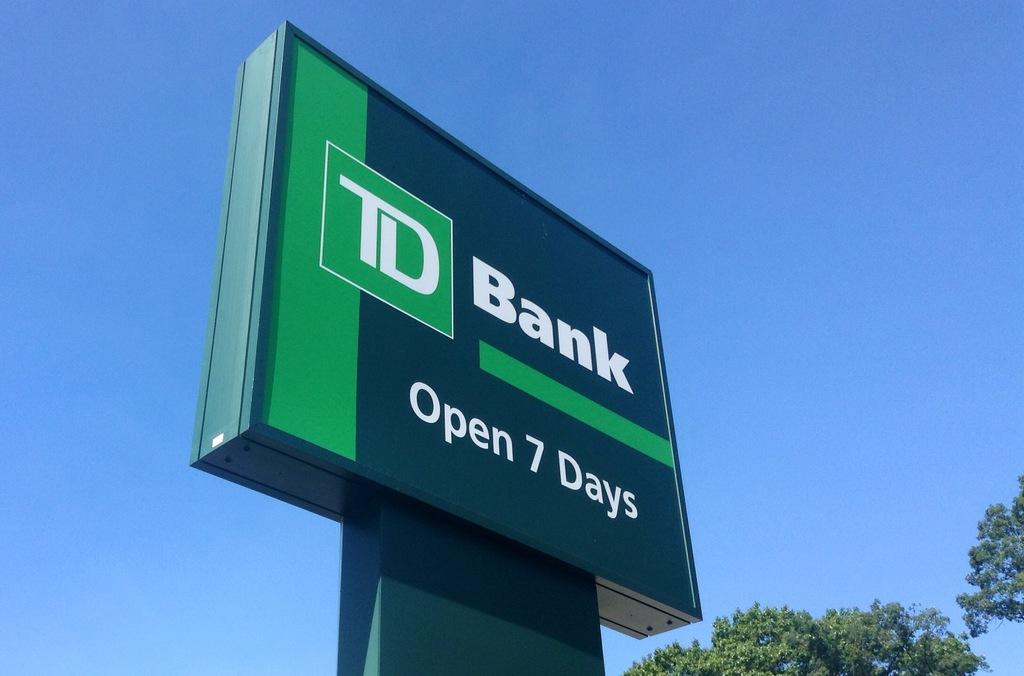What days is this bank open?
Provide a succinct answer. 7 days. What is the name of the bank?
Your answer should be compact. Td bank. 